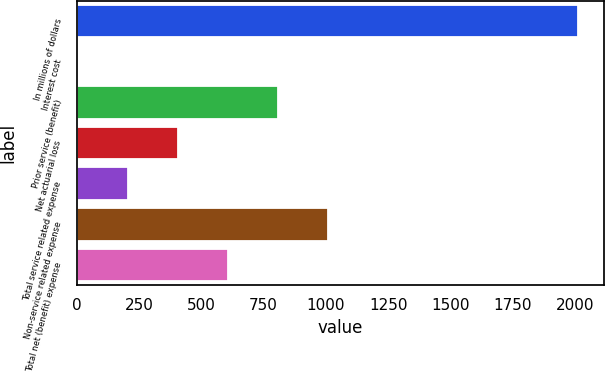Convert chart to OTSL. <chart><loc_0><loc_0><loc_500><loc_500><bar_chart><fcel>In millions of dollars<fcel>Interest cost<fcel>Prior service (benefit)<fcel>Net actuarial loss<fcel>Total service related expense<fcel>Non-service related expense<fcel>Total net (benefit) expense<nl><fcel>2014<fcel>5<fcel>808.6<fcel>406.8<fcel>205.9<fcel>1009.5<fcel>607.7<nl></chart> 